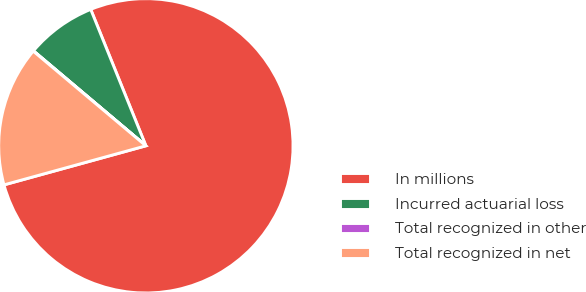<chart> <loc_0><loc_0><loc_500><loc_500><pie_chart><fcel>In millions<fcel>Incurred actuarial loss<fcel>Total recognized in other<fcel>Total recognized in net<nl><fcel>76.84%<fcel>7.72%<fcel>0.04%<fcel>15.4%<nl></chart> 